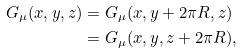<formula> <loc_0><loc_0><loc_500><loc_500>G _ { \mu } ( x , y , z ) & = G _ { \mu } ( x , y + 2 \pi R , z ) \\ & = G _ { \mu } ( x , y , z + 2 \pi R ) ,</formula> 